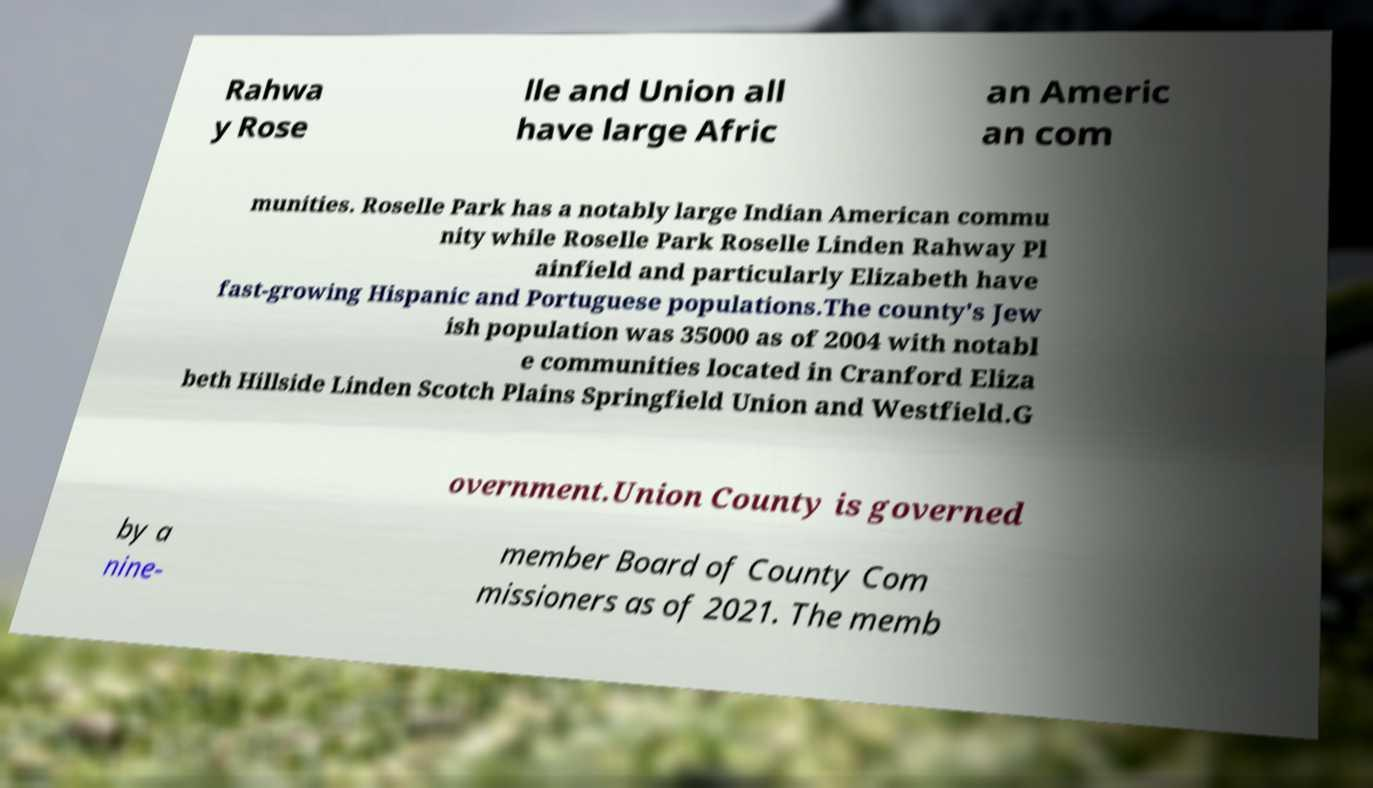Can you read and provide the text displayed in the image?This photo seems to have some interesting text. Can you extract and type it out for me? Rahwa y Rose lle and Union all have large Afric an Americ an com munities. Roselle Park has a notably large Indian American commu nity while Roselle Park Roselle Linden Rahway Pl ainfield and particularly Elizabeth have fast-growing Hispanic and Portuguese populations.The county's Jew ish population was 35000 as of 2004 with notabl e communities located in Cranford Eliza beth Hillside Linden Scotch Plains Springfield Union and Westfield.G overnment.Union County is governed by a nine- member Board of County Com missioners as of 2021. The memb 